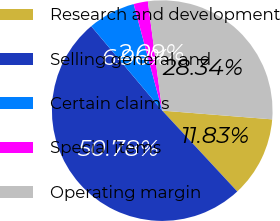Convert chart to OTSL. <chart><loc_0><loc_0><loc_500><loc_500><pie_chart><fcel>Research and development<fcel>Selling general and<fcel>Certain claims<fcel>Special items<fcel>Operating margin<nl><fcel>11.83%<fcel>50.77%<fcel>6.96%<fcel>2.09%<fcel>28.34%<nl></chart> 